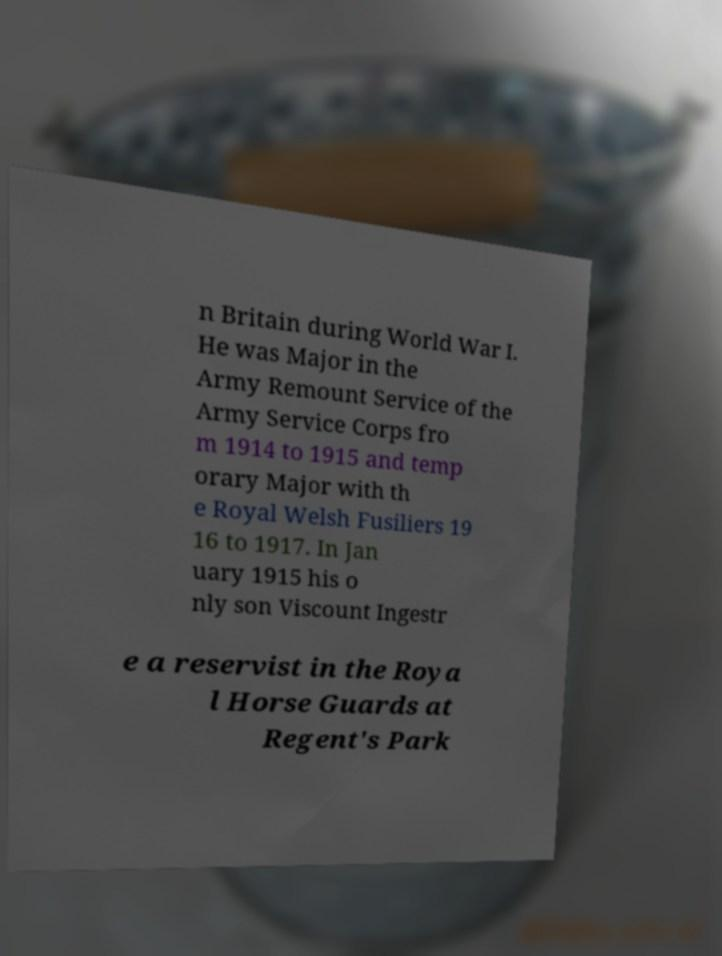I need the written content from this picture converted into text. Can you do that? n Britain during World War I. He was Major in the Army Remount Service of the Army Service Corps fro m 1914 to 1915 and temp orary Major with th e Royal Welsh Fusiliers 19 16 to 1917. In Jan uary 1915 his o nly son Viscount Ingestr e a reservist in the Roya l Horse Guards at Regent's Park 